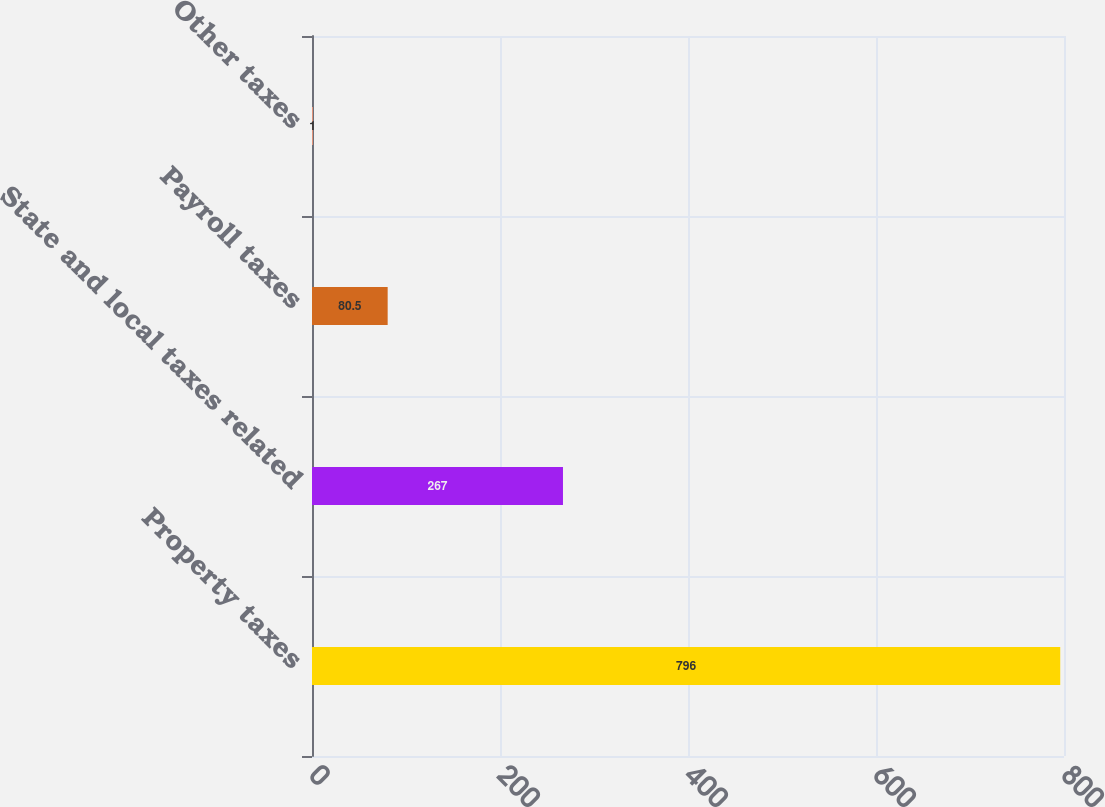Convert chart. <chart><loc_0><loc_0><loc_500><loc_500><bar_chart><fcel>Property taxes<fcel>State and local taxes related<fcel>Payroll taxes<fcel>Other taxes<nl><fcel>796<fcel>267<fcel>80.5<fcel>1<nl></chart> 